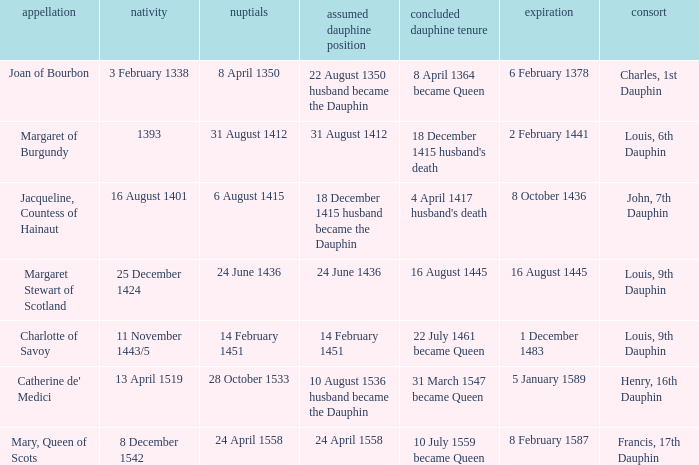Who is the husband when ceased to be dauphine is 22 july 1461 became queen? Louis, 9th Dauphin. 